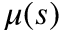<formula> <loc_0><loc_0><loc_500><loc_500>\mu ( s )</formula> 